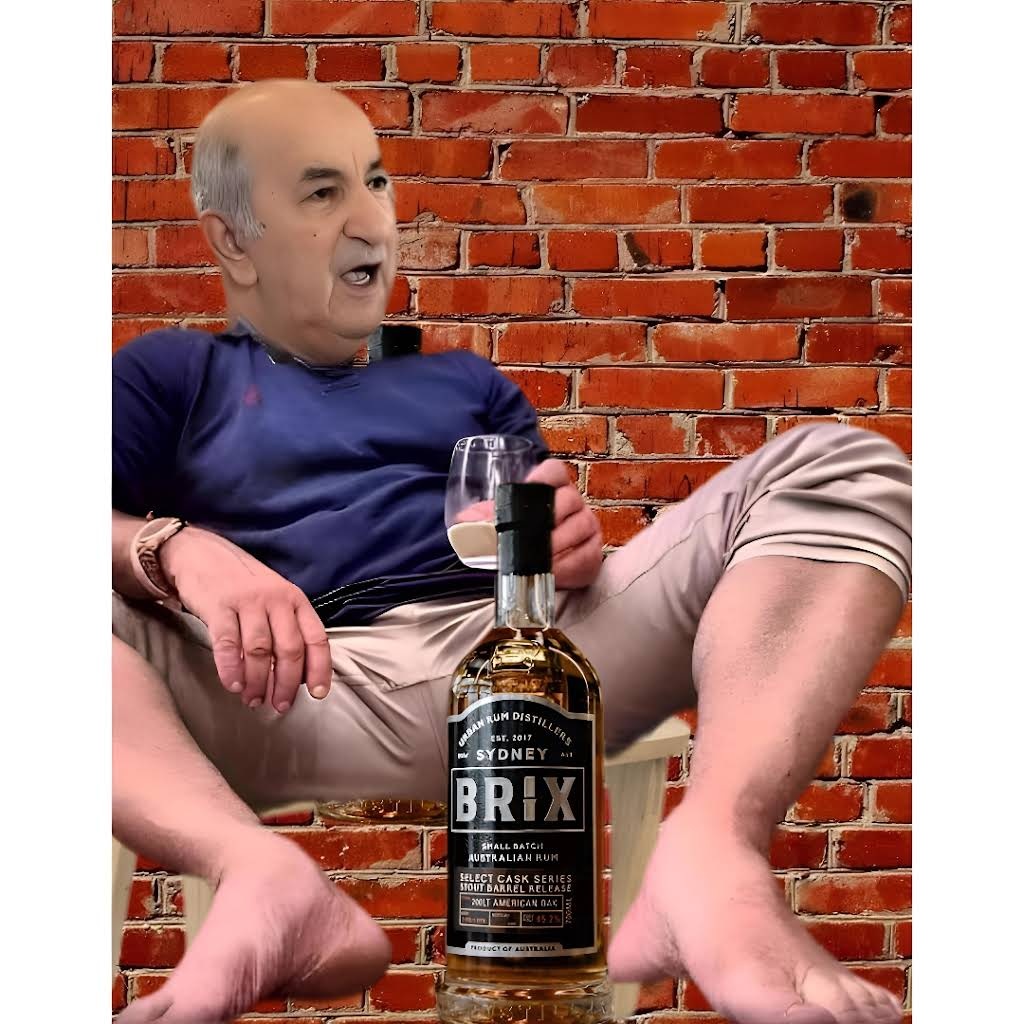faire bouge la tete - Salut, je suis Bouteflika.
- Je suis un ancien président de l'Algérie.
- J'ai démissionné en 2019 après 20 ans au pouvoir.
- J'ai été accusé de corruption et de fraude électorale.
- Je suis maintenant en résidence surveillée.
- Je suis malade et je ne peux plus m'occuper de mes affaires.
- Je demande pardon au peuple algérien.
- Je souhaite que l'Algérie soit un pays démocratique et prospère.
- Merci. 